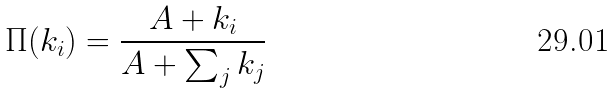Convert formula to latex. <formula><loc_0><loc_0><loc_500><loc_500>\Pi ( k _ { i } ) = \frac { A + k _ { i } } { A + \sum _ { j } k _ { j } }</formula> 